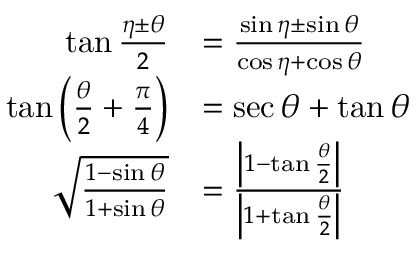Convert formula to latex. <formula><loc_0><loc_0><loc_500><loc_500>{ \begin{array} { r l } { \tan { \frac { \eta \pm \theta } { 2 } } } & { = { \frac { \sin \eta \pm \sin \theta } { \cos \eta + \cos \theta } } } \\ { \tan \left ( { \frac { \theta } { 2 } } + { \frac { \pi } { 4 } } \right ) } & { = \sec \theta + \tan \theta } \\ { { \sqrt { \frac { 1 - \sin \theta } { 1 + \sin \theta } } } } & { = { \frac { \left | 1 - \tan { \frac { \theta } { 2 } } \right | } { \left | 1 + \tan { \frac { \theta } { 2 } } \right | } } } \end{array} }</formula> 